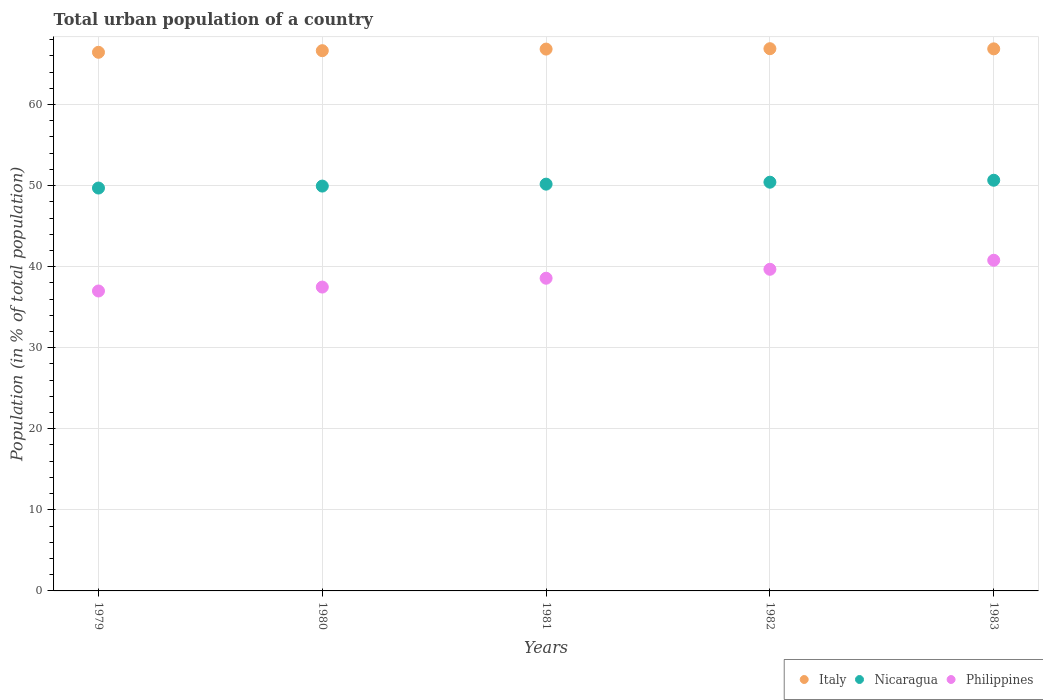How many different coloured dotlines are there?
Keep it short and to the point. 3. Is the number of dotlines equal to the number of legend labels?
Keep it short and to the point. Yes. What is the urban population in Nicaragua in 1982?
Make the answer very short. 50.42. Across all years, what is the maximum urban population in Nicaragua?
Provide a succinct answer. 50.66. Across all years, what is the minimum urban population in Philippines?
Ensure brevity in your answer.  37. In which year was the urban population in Philippines minimum?
Offer a very short reply. 1979. What is the total urban population in Italy in the graph?
Provide a succinct answer. 333.67. What is the difference between the urban population in Philippines in 1981 and that in 1982?
Your answer should be compact. -1.1. What is the difference between the urban population in Italy in 1981 and the urban population in Philippines in 1982?
Provide a succinct answer. 27.16. What is the average urban population in Philippines per year?
Provide a succinct answer. 38.7. In the year 1979, what is the difference between the urban population in Philippines and urban population in Nicaragua?
Give a very brief answer. -12.7. What is the ratio of the urban population in Nicaragua in 1982 to that in 1983?
Your response must be concise. 1. Is the urban population in Nicaragua in 1980 less than that in 1982?
Your answer should be compact. Yes. What is the difference between the highest and the second highest urban population in Nicaragua?
Keep it short and to the point. 0.24. What is the difference between the highest and the lowest urban population in Italy?
Give a very brief answer. 0.44. In how many years, is the urban population in Nicaragua greater than the average urban population in Nicaragua taken over all years?
Make the answer very short. 2. Is the sum of the urban population in Italy in 1980 and 1982 greater than the maximum urban population in Philippines across all years?
Make the answer very short. Yes. Is it the case that in every year, the sum of the urban population in Nicaragua and urban population in Italy  is greater than the urban population in Philippines?
Ensure brevity in your answer.  Yes. Does the urban population in Philippines monotonically increase over the years?
Make the answer very short. Yes. How many dotlines are there?
Provide a succinct answer. 3. How many years are there in the graph?
Make the answer very short. 5. What is the difference between two consecutive major ticks on the Y-axis?
Your answer should be very brief. 10. Does the graph contain grids?
Provide a short and direct response. Yes. Where does the legend appear in the graph?
Make the answer very short. Bottom right. How many legend labels are there?
Provide a short and direct response. 3. How are the legend labels stacked?
Give a very brief answer. Horizontal. What is the title of the graph?
Your answer should be compact. Total urban population of a country. What is the label or title of the Y-axis?
Make the answer very short. Population (in % of total population). What is the Population (in % of total population) of Italy in 1979?
Offer a very short reply. 66.44. What is the Population (in % of total population) in Nicaragua in 1979?
Your answer should be very brief. 49.7. What is the Population (in % of total population) of Philippines in 1979?
Your response must be concise. 37. What is the Population (in % of total population) in Italy in 1980?
Give a very brief answer. 66.64. What is the Population (in % of total population) in Nicaragua in 1980?
Make the answer very short. 49.94. What is the Population (in % of total population) of Philippines in 1980?
Provide a succinct answer. 37.48. What is the Population (in % of total population) of Italy in 1981?
Ensure brevity in your answer.  66.84. What is the Population (in % of total population) of Nicaragua in 1981?
Ensure brevity in your answer.  50.18. What is the Population (in % of total population) in Philippines in 1981?
Provide a succinct answer. 38.57. What is the Population (in % of total population) of Italy in 1982?
Ensure brevity in your answer.  66.89. What is the Population (in % of total population) of Nicaragua in 1982?
Keep it short and to the point. 50.42. What is the Population (in % of total population) of Philippines in 1982?
Keep it short and to the point. 39.67. What is the Population (in % of total population) of Italy in 1983?
Provide a succinct answer. 66.87. What is the Population (in % of total population) of Nicaragua in 1983?
Give a very brief answer. 50.66. What is the Population (in % of total population) in Philippines in 1983?
Provide a succinct answer. 40.79. Across all years, what is the maximum Population (in % of total population) in Italy?
Offer a terse response. 66.89. Across all years, what is the maximum Population (in % of total population) of Nicaragua?
Offer a very short reply. 50.66. Across all years, what is the maximum Population (in % of total population) of Philippines?
Keep it short and to the point. 40.79. Across all years, what is the minimum Population (in % of total population) of Italy?
Provide a succinct answer. 66.44. Across all years, what is the minimum Population (in % of total population) in Nicaragua?
Your response must be concise. 49.7. Across all years, what is the minimum Population (in % of total population) of Philippines?
Provide a short and direct response. 37. What is the total Population (in % of total population) in Italy in the graph?
Offer a very short reply. 333.67. What is the total Population (in % of total population) of Nicaragua in the graph?
Offer a terse response. 250.89. What is the total Population (in % of total population) in Philippines in the graph?
Provide a succinct answer. 193.51. What is the difference between the Population (in % of total population) in Italy in 1979 and that in 1980?
Your response must be concise. -0.2. What is the difference between the Population (in % of total population) of Nicaragua in 1979 and that in 1980?
Offer a terse response. -0.24. What is the difference between the Population (in % of total population) in Philippines in 1979 and that in 1980?
Give a very brief answer. -0.48. What is the difference between the Population (in % of total population) in Italy in 1979 and that in 1981?
Provide a short and direct response. -0.4. What is the difference between the Population (in % of total population) in Nicaragua in 1979 and that in 1981?
Provide a short and direct response. -0.48. What is the difference between the Population (in % of total population) of Philippines in 1979 and that in 1981?
Provide a succinct answer. -1.57. What is the difference between the Population (in % of total population) of Italy in 1979 and that in 1982?
Ensure brevity in your answer.  -0.44. What is the difference between the Population (in % of total population) of Nicaragua in 1979 and that in 1982?
Your response must be concise. -0.72. What is the difference between the Population (in % of total population) in Philippines in 1979 and that in 1982?
Keep it short and to the point. -2.68. What is the difference between the Population (in % of total population) in Italy in 1979 and that in 1983?
Provide a succinct answer. -0.42. What is the difference between the Population (in % of total population) in Nicaragua in 1979 and that in 1983?
Make the answer very short. -0.96. What is the difference between the Population (in % of total population) of Philippines in 1979 and that in 1983?
Offer a terse response. -3.79. What is the difference between the Population (in % of total population) in Italy in 1980 and that in 1981?
Offer a terse response. -0.2. What is the difference between the Population (in % of total population) of Nicaragua in 1980 and that in 1981?
Offer a very short reply. -0.24. What is the difference between the Population (in % of total population) of Philippines in 1980 and that in 1981?
Provide a succinct answer. -1.09. What is the difference between the Population (in % of total population) in Italy in 1980 and that in 1982?
Provide a succinct answer. -0.25. What is the difference between the Population (in % of total population) of Nicaragua in 1980 and that in 1982?
Give a very brief answer. -0.48. What is the difference between the Population (in % of total population) in Philippines in 1980 and that in 1982?
Provide a succinct answer. -2.19. What is the difference between the Population (in % of total population) of Italy in 1980 and that in 1983?
Your response must be concise. -0.23. What is the difference between the Population (in % of total population) of Nicaragua in 1980 and that in 1983?
Your answer should be compact. -0.72. What is the difference between the Population (in % of total population) of Philippines in 1980 and that in 1983?
Ensure brevity in your answer.  -3.31. What is the difference between the Population (in % of total population) in Italy in 1981 and that in 1982?
Make the answer very short. -0.05. What is the difference between the Population (in % of total population) of Nicaragua in 1981 and that in 1982?
Provide a succinct answer. -0.24. What is the difference between the Population (in % of total population) in Philippines in 1981 and that in 1982?
Give a very brief answer. -1.1. What is the difference between the Population (in % of total population) in Italy in 1981 and that in 1983?
Make the answer very short. -0.03. What is the difference between the Population (in % of total population) of Nicaragua in 1981 and that in 1983?
Keep it short and to the point. -0.48. What is the difference between the Population (in % of total population) in Philippines in 1981 and that in 1983?
Your answer should be compact. -2.22. What is the difference between the Population (in % of total population) in Nicaragua in 1982 and that in 1983?
Give a very brief answer. -0.24. What is the difference between the Population (in % of total population) of Philippines in 1982 and that in 1983?
Keep it short and to the point. -1.11. What is the difference between the Population (in % of total population) in Italy in 1979 and the Population (in % of total population) in Nicaragua in 1980?
Your answer should be compact. 16.5. What is the difference between the Population (in % of total population) in Italy in 1979 and the Population (in % of total population) in Philippines in 1980?
Your response must be concise. 28.96. What is the difference between the Population (in % of total population) of Nicaragua in 1979 and the Population (in % of total population) of Philippines in 1980?
Keep it short and to the point. 12.22. What is the difference between the Population (in % of total population) in Italy in 1979 and the Population (in % of total population) in Nicaragua in 1981?
Your answer should be compact. 16.27. What is the difference between the Population (in % of total population) in Italy in 1979 and the Population (in % of total population) in Philippines in 1981?
Provide a succinct answer. 27.87. What is the difference between the Population (in % of total population) of Nicaragua in 1979 and the Population (in % of total population) of Philippines in 1981?
Provide a succinct answer. 11.13. What is the difference between the Population (in % of total population) of Italy in 1979 and the Population (in % of total population) of Nicaragua in 1982?
Your answer should be compact. 16.02. What is the difference between the Population (in % of total population) in Italy in 1979 and the Population (in % of total population) in Philippines in 1982?
Offer a terse response. 26.77. What is the difference between the Population (in % of total population) of Nicaragua in 1979 and the Population (in % of total population) of Philippines in 1982?
Keep it short and to the point. 10.02. What is the difference between the Population (in % of total population) of Italy in 1979 and the Population (in % of total population) of Nicaragua in 1983?
Your response must be concise. 15.78. What is the difference between the Population (in % of total population) of Italy in 1979 and the Population (in % of total population) of Philippines in 1983?
Ensure brevity in your answer.  25.65. What is the difference between the Population (in % of total population) in Nicaragua in 1979 and the Population (in % of total population) in Philippines in 1983?
Your response must be concise. 8.91. What is the difference between the Population (in % of total population) in Italy in 1980 and the Population (in % of total population) in Nicaragua in 1981?
Make the answer very short. 16.46. What is the difference between the Population (in % of total population) of Italy in 1980 and the Population (in % of total population) of Philippines in 1981?
Your answer should be compact. 28.07. What is the difference between the Population (in % of total population) in Nicaragua in 1980 and the Population (in % of total population) in Philippines in 1981?
Make the answer very short. 11.37. What is the difference between the Population (in % of total population) in Italy in 1980 and the Population (in % of total population) in Nicaragua in 1982?
Offer a very short reply. 16.22. What is the difference between the Population (in % of total population) of Italy in 1980 and the Population (in % of total population) of Philippines in 1982?
Your answer should be very brief. 26.96. What is the difference between the Population (in % of total population) in Nicaragua in 1980 and the Population (in % of total population) in Philippines in 1982?
Your answer should be very brief. 10.26. What is the difference between the Population (in % of total population) of Italy in 1980 and the Population (in % of total population) of Nicaragua in 1983?
Ensure brevity in your answer.  15.98. What is the difference between the Population (in % of total population) in Italy in 1980 and the Population (in % of total population) in Philippines in 1983?
Make the answer very short. 25.85. What is the difference between the Population (in % of total population) of Nicaragua in 1980 and the Population (in % of total population) of Philippines in 1983?
Provide a short and direct response. 9.15. What is the difference between the Population (in % of total population) in Italy in 1981 and the Population (in % of total population) in Nicaragua in 1982?
Give a very brief answer. 16.42. What is the difference between the Population (in % of total population) in Italy in 1981 and the Population (in % of total population) in Philippines in 1982?
Give a very brief answer. 27.16. What is the difference between the Population (in % of total population) of Nicaragua in 1981 and the Population (in % of total population) of Philippines in 1982?
Your response must be concise. 10.5. What is the difference between the Population (in % of total population) in Italy in 1981 and the Population (in % of total population) in Nicaragua in 1983?
Your response must be concise. 16.18. What is the difference between the Population (in % of total population) of Italy in 1981 and the Population (in % of total population) of Philippines in 1983?
Provide a short and direct response. 26.05. What is the difference between the Population (in % of total population) in Nicaragua in 1981 and the Population (in % of total population) in Philippines in 1983?
Provide a succinct answer. 9.39. What is the difference between the Population (in % of total population) in Italy in 1982 and the Population (in % of total population) in Nicaragua in 1983?
Give a very brief answer. 16.23. What is the difference between the Population (in % of total population) in Italy in 1982 and the Population (in % of total population) in Philippines in 1983?
Offer a very short reply. 26.1. What is the difference between the Population (in % of total population) in Nicaragua in 1982 and the Population (in % of total population) in Philippines in 1983?
Ensure brevity in your answer.  9.63. What is the average Population (in % of total population) in Italy per year?
Your response must be concise. 66.73. What is the average Population (in % of total population) of Nicaragua per year?
Give a very brief answer. 50.18. What is the average Population (in % of total population) of Philippines per year?
Ensure brevity in your answer.  38.7. In the year 1979, what is the difference between the Population (in % of total population) of Italy and Population (in % of total population) of Nicaragua?
Your answer should be compact. 16.75. In the year 1979, what is the difference between the Population (in % of total population) in Italy and Population (in % of total population) in Philippines?
Your answer should be compact. 29.45. In the year 1979, what is the difference between the Population (in % of total population) in Nicaragua and Population (in % of total population) in Philippines?
Ensure brevity in your answer.  12.7. In the year 1980, what is the difference between the Population (in % of total population) of Italy and Population (in % of total population) of Nicaragua?
Your response must be concise. 16.7. In the year 1980, what is the difference between the Population (in % of total population) in Italy and Population (in % of total population) in Philippines?
Offer a very short reply. 29.16. In the year 1980, what is the difference between the Population (in % of total population) in Nicaragua and Population (in % of total population) in Philippines?
Ensure brevity in your answer.  12.46. In the year 1981, what is the difference between the Population (in % of total population) in Italy and Population (in % of total population) in Nicaragua?
Offer a very short reply. 16.66. In the year 1981, what is the difference between the Population (in % of total population) in Italy and Population (in % of total population) in Philippines?
Provide a short and direct response. 28.27. In the year 1981, what is the difference between the Population (in % of total population) of Nicaragua and Population (in % of total population) of Philippines?
Your answer should be compact. 11.61. In the year 1982, what is the difference between the Population (in % of total population) in Italy and Population (in % of total population) in Nicaragua?
Provide a succinct answer. 16.47. In the year 1982, what is the difference between the Population (in % of total population) in Italy and Population (in % of total population) in Philippines?
Offer a terse response. 27.21. In the year 1982, what is the difference between the Population (in % of total population) of Nicaragua and Population (in % of total population) of Philippines?
Keep it short and to the point. 10.74. In the year 1983, what is the difference between the Population (in % of total population) in Italy and Population (in % of total population) in Nicaragua?
Ensure brevity in your answer.  16.21. In the year 1983, what is the difference between the Population (in % of total population) in Italy and Population (in % of total population) in Philippines?
Ensure brevity in your answer.  26.08. In the year 1983, what is the difference between the Population (in % of total population) in Nicaragua and Population (in % of total population) in Philippines?
Keep it short and to the point. 9.87. What is the ratio of the Population (in % of total population) in Nicaragua in 1979 to that in 1980?
Keep it short and to the point. 1. What is the ratio of the Population (in % of total population) in Philippines in 1979 to that in 1980?
Ensure brevity in your answer.  0.99. What is the ratio of the Population (in % of total population) in Italy in 1979 to that in 1981?
Keep it short and to the point. 0.99. What is the ratio of the Population (in % of total population) in Philippines in 1979 to that in 1981?
Provide a succinct answer. 0.96. What is the ratio of the Population (in % of total population) of Nicaragua in 1979 to that in 1982?
Offer a terse response. 0.99. What is the ratio of the Population (in % of total population) of Philippines in 1979 to that in 1982?
Ensure brevity in your answer.  0.93. What is the ratio of the Population (in % of total population) of Italy in 1979 to that in 1983?
Your answer should be very brief. 0.99. What is the ratio of the Population (in % of total population) in Nicaragua in 1979 to that in 1983?
Give a very brief answer. 0.98. What is the ratio of the Population (in % of total population) of Philippines in 1979 to that in 1983?
Keep it short and to the point. 0.91. What is the ratio of the Population (in % of total population) in Nicaragua in 1980 to that in 1981?
Make the answer very short. 1. What is the ratio of the Population (in % of total population) in Philippines in 1980 to that in 1981?
Provide a short and direct response. 0.97. What is the ratio of the Population (in % of total population) of Italy in 1980 to that in 1982?
Your answer should be compact. 1. What is the ratio of the Population (in % of total population) in Philippines in 1980 to that in 1982?
Your answer should be very brief. 0.94. What is the ratio of the Population (in % of total population) in Nicaragua in 1980 to that in 1983?
Keep it short and to the point. 0.99. What is the ratio of the Population (in % of total population) in Philippines in 1980 to that in 1983?
Your response must be concise. 0.92. What is the ratio of the Population (in % of total population) in Italy in 1981 to that in 1982?
Offer a terse response. 1. What is the ratio of the Population (in % of total population) of Philippines in 1981 to that in 1982?
Ensure brevity in your answer.  0.97. What is the ratio of the Population (in % of total population) of Nicaragua in 1981 to that in 1983?
Keep it short and to the point. 0.99. What is the ratio of the Population (in % of total population) in Philippines in 1981 to that in 1983?
Offer a terse response. 0.95. What is the ratio of the Population (in % of total population) in Italy in 1982 to that in 1983?
Keep it short and to the point. 1. What is the ratio of the Population (in % of total population) of Philippines in 1982 to that in 1983?
Keep it short and to the point. 0.97. What is the difference between the highest and the second highest Population (in % of total population) of Italy?
Offer a very short reply. 0.02. What is the difference between the highest and the second highest Population (in % of total population) in Nicaragua?
Provide a succinct answer. 0.24. What is the difference between the highest and the second highest Population (in % of total population) in Philippines?
Your response must be concise. 1.11. What is the difference between the highest and the lowest Population (in % of total population) of Italy?
Give a very brief answer. 0.44. What is the difference between the highest and the lowest Population (in % of total population) of Nicaragua?
Your response must be concise. 0.96. What is the difference between the highest and the lowest Population (in % of total population) in Philippines?
Your answer should be compact. 3.79. 